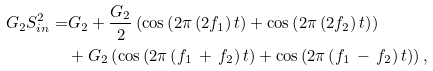<formula> <loc_0><loc_0><loc_500><loc_500>G _ { 2 } S _ { i n } ^ { 2 } = & G _ { 2 } + \frac { G _ { 2 } } { 2 } \left ( \cos \left ( 2 \pi \left ( 2 f _ { 1 } \right ) t \right ) + \cos \left ( 2 \pi \left ( 2 f _ { 2 } \right ) t \right ) \right ) \\ & + G _ { 2 } \left ( \cos \left ( 2 \pi \left ( f _ { 1 } \, + \, f _ { 2 } \right ) t \right ) + \cos \left ( 2 \pi \left ( f _ { 1 } \, - \, f _ { 2 } \right ) t \right ) \right ) , \\</formula> 